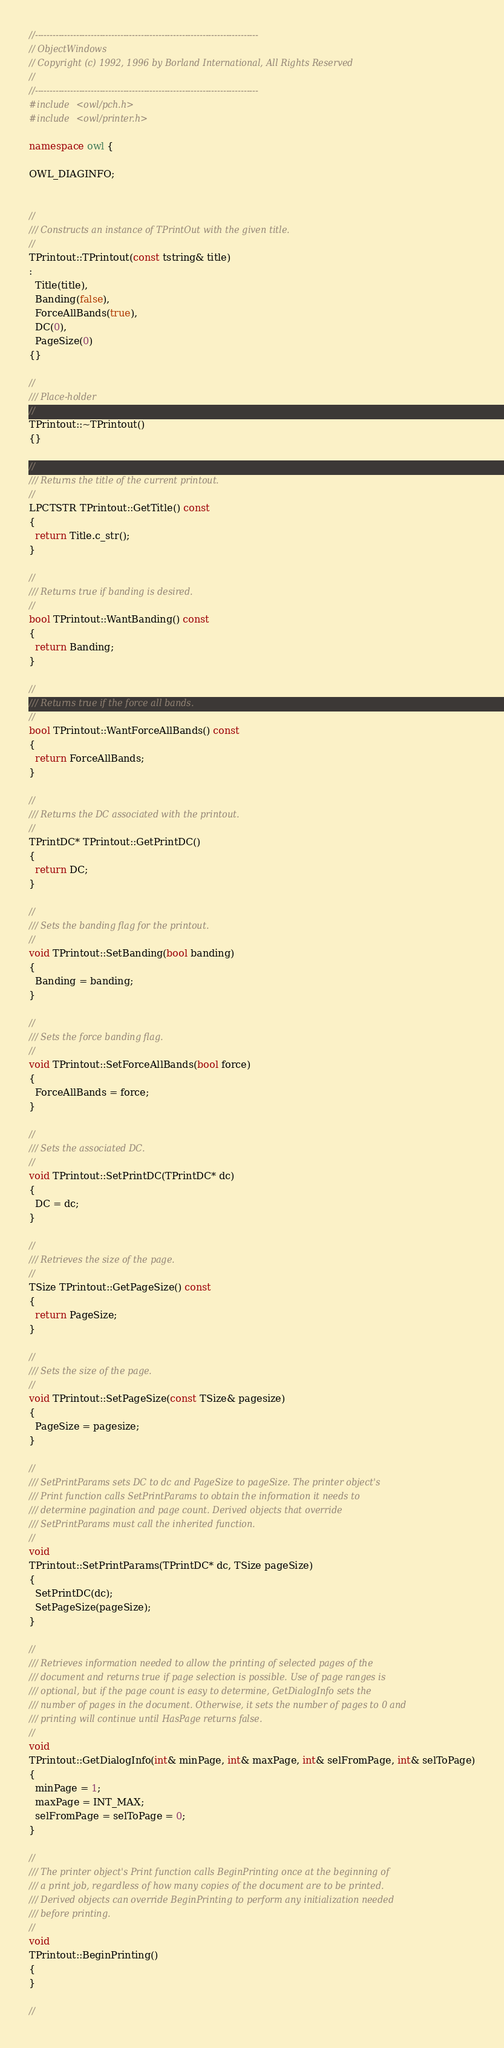Convert code to text. <code><loc_0><loc_0><loc_500><loc_500><_C++_>//----------------------------------------------------------------------------
// ObjectWindows
// Copyright (c) 1992, 1996 by Borland International, All Rights Reserved
//
//----------------------------------------------------------------------------
#include <owl/pch.h>
#include <owl/printer.h>

namespace owl {

OWL_DIAGINFO;


//
/// Constructs an instance of TPrintOut with the given title.
//
TPrintout::TPrintout(const tstring& title)
:
  Title(title),
  Banding(false),
  ForceAllBands(true),
  DC(0),
  PageSize(0)
{}

//
/// Place-holder
//
TPrintout::~TPrintout()
{}

//
/// Returns the title of the current printout.
//
LPCTSTR TPrintout::GetTitle() const
{
  return Title.c_str();
}

//
/// Returns true if banding is desired.
//
bool TPrintout::WantBanding() const
{
  return Banding;
}

//
/// Returns true if the force all bands.
//
bool TPrintout::WantForceAllBands() const
{
  return ForceAllBands;
}

//
/// Returns the DC associated with the printout.
//
TPrintDC* TPrintout::GetPrintDC()
{
  return DC;
}

//
/// Sets the banding flag for the printout.
//
void TPrintout::SetBanding(bool banding)
{
  Banding = banding;
}

//
/// Sets the force banding flag.
//
void TPrintout::SetForceAllBands(bool force)
{
  ForceAllBands = force;
}

//
/// Sets the associated DC.
//
void TPrintout::SetPrintDC(TPrintDC* dc)
{
  DC = dc;
}

//
/// Retrieves the size of the page.
//
TSize TPrintout::GetPageSize() const
{
  return PageSize;
}

//
/// Sets the size of the page.
//
void TPrintout::SetPageSize(const TSize& pagesize)
{
  PageSize = pagesize;
}

//
/// SetPrintParams sets DC to dc and PageSize to pageSize. The printer object's
/// Print function calls SetPrintParams to obtain the information it needs to
/// determine pagination and page count. Derived objects that override
/// SetPrintParams must call the inherited function.
//
void
TPrintout::SetPrintParams(TPrintDC* dc, TSize pageSize)
{
  SetPrintDC(dc);
  SetPageSize(pageSize);
}

//
/// Retrieves information needed to allow the printing of selected pages of the
/// document and returns true if page selection is possible. Use of page ranges is
/// optional, but if the page count is easy to determine, GetDialogInfo sets the
/// number of pages in the document. Otherwise, it sets the number of pages to 0 and
/// printing will continue until HasPage returns false.
//
void
TPrintout::GetDialogInfo(int& minPage, int& maxPage, int& selFromPage, int& selToPage)
{
  minPage = 1;
  maxPage = INT_MAX;
  selFromPage = selToPage = 0;
}

//
/// The printer object's Print function calls BeginPrinting once at the beginning of
/// a print job, regardless of how many copies of the document are to be printed.
/// Derived objects can override BeginPrinting to perform any initialization needed
/// before printing.
//
void
TPrintout::BeginPrinting()
{
}

//</code> 